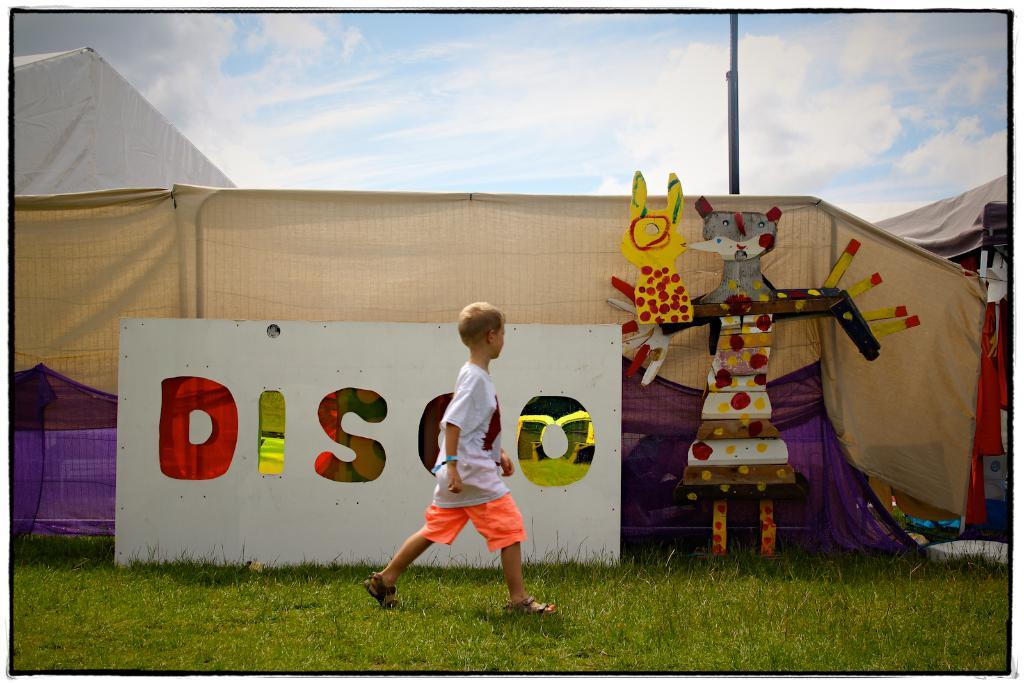<image>
Write a terse but informative summary of the picture. The child is walking by a white "disco" sign. 